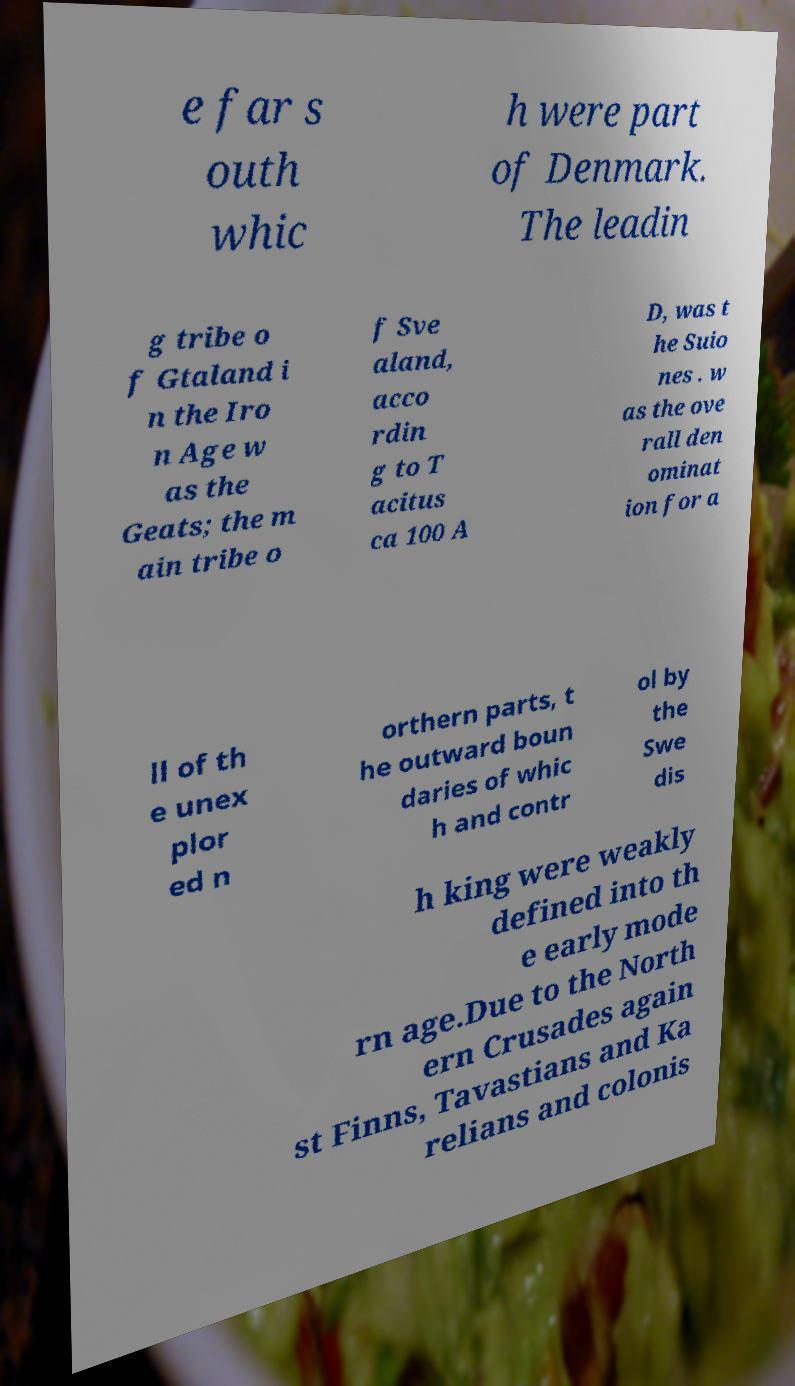For documentation purposes, I need the text within this image transcribed. Could you provide that? e far s outh whic h were part of Denmark. The leadin g tribe o f Gtaland i n the Iro n Age w as the Geats; the m ain tribe o f Sve aland, acco rdin g to T acitus ca 100 A D, was t he Suio nes . w as the ove rall den ominat ion for a ll of th e unex plor ed n orthern parts, t he outward boun daries of whic h and contr ol by the Swe dis h king were weakly defined into th e early mode rn age.Due to the North ern Crusades again st Finns, Tavastians and Ka relians and colonis 